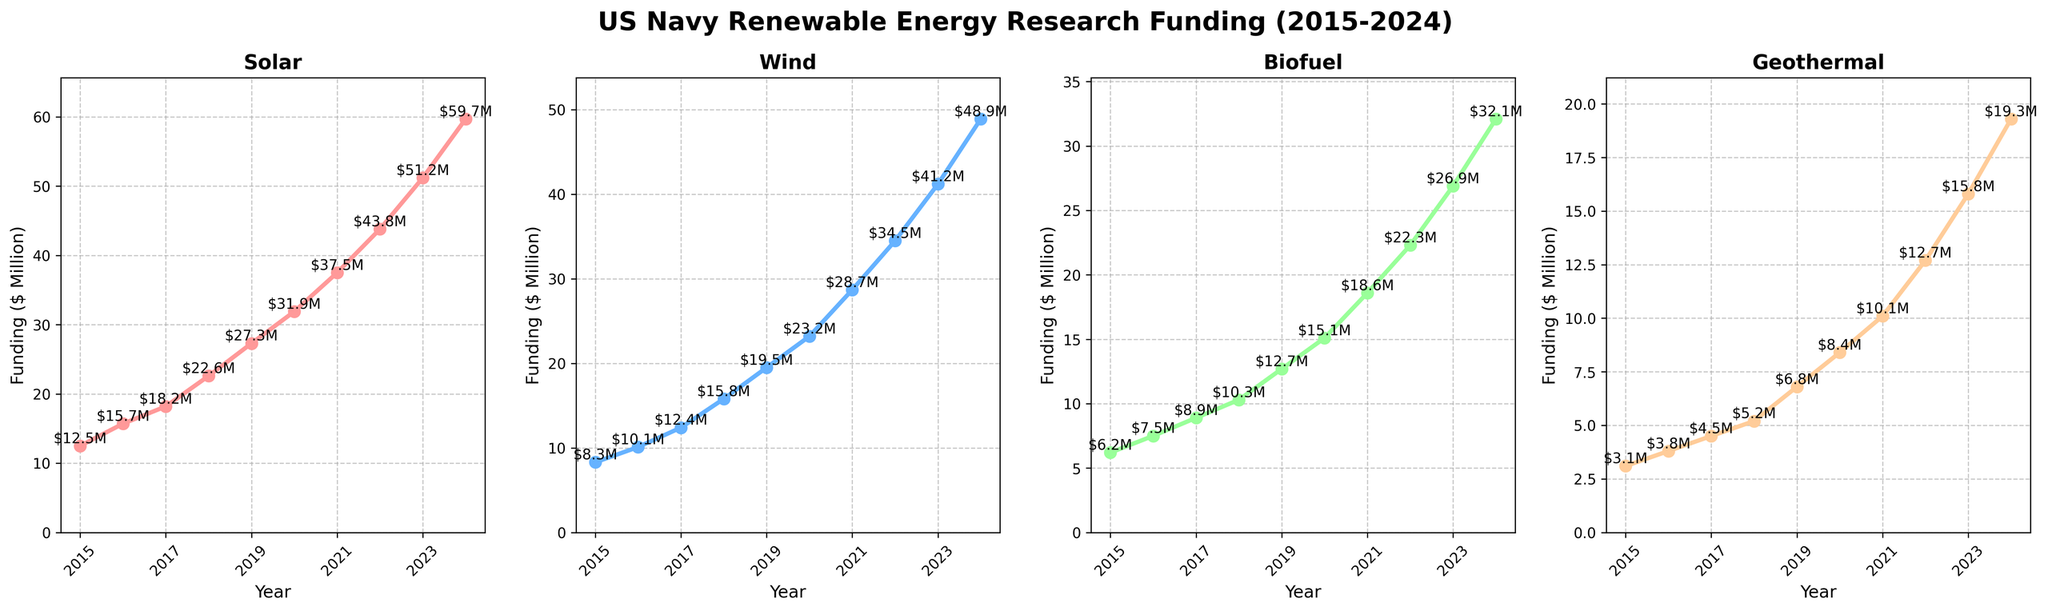How has the funding for Solar and Wind energy research changed from 2015 to 2024? To determine the change in funding, we subtract the 2015 values from the 2024 values. Solar funding increased from $12.5M to $59.7M, a difference of $47.2M. Wind funding increased from $8.3M to $48.9M, a difference of $40.6M.
Answer: Solar: $47.2M, Wind: $40.6M In which year was the funding for Biofuel research equal to the funding for Geothermal research? We compare the Biofuel and Geothermal funding values for each year to find the match. In 2015, Biofuel funding was $6.2M, and Geothermal was $3.1M. These values are unequal for all years.
Answer: Never What is the total renewable energy funding for 2022? We sum the funding amounts for Solar, Wind, Biofuel, and Geothermal for the year 2022: $43.8M, $34.5M, $22.3M, and $12.7M respectively. The total is $43.8M + $34.5M + $22.3M + $12.7M = $113.3M.
Answer: $113.3M Which renewable energy source saw the most significant increase in funding over the years? To determine this, we calculate the difference between the 2015 and 2024 values for each energy source. Solar funding increased by $47.2M, Wind by $40.6M, Biofuel by $25.9M, and Geothermal by $16.2M. Solar saw the most significant increase.
Answer: Solar What is the average annual funding for Wind energy from 2015 to 2024? We sum the annual funding for Wind energy from 2015 to 2024 and then divide by the number of years (10). The total funding is $252.6M, so the average is $252.6M / 10 = $25.26M.
Answer: $25.26M In which year did the funding for Geothermal research surpass $5 million? By examining the Geothermal funding values, we see that in 2018 it reaches $5.2M, surpassing $5M.
Answer: 2018 Compare the funding growth trends between Solar and Biofuel from 2015 to 2024. Solar funding increased from $12.5M to $59.7M, a $47.2M increase. Biofuel funding increased from $6.2M to $32.1M, a $25.9M increase. Both saw steady growth, but Solar experienced a larger absolute increase.
Answer: Solar saw higher growth How does the 2023 funding for Biofuel compare to the 2020 funding for Solar? The 2023 Biofuel funding is $26.9M, while the 2020 Solar funding is $31.9M. Thus, the Biofuel funding in 2023 is lower than the Solar funding in 2020.
Answer: Biofuel: $26.9M, Solar: $31.9M Which funding line shows the steepest slope on the plot? The slope represents the rate of increase in funding. By visually inspecting the steepness of the lines, the plot for Solar funding has the steepest slope, indicating the fastest rate of increase.
Answer: Solar 